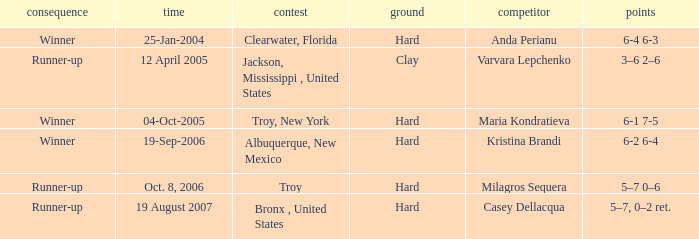What is the score of the game that was played against Maria Kondratieva? 6-1 7-5. 